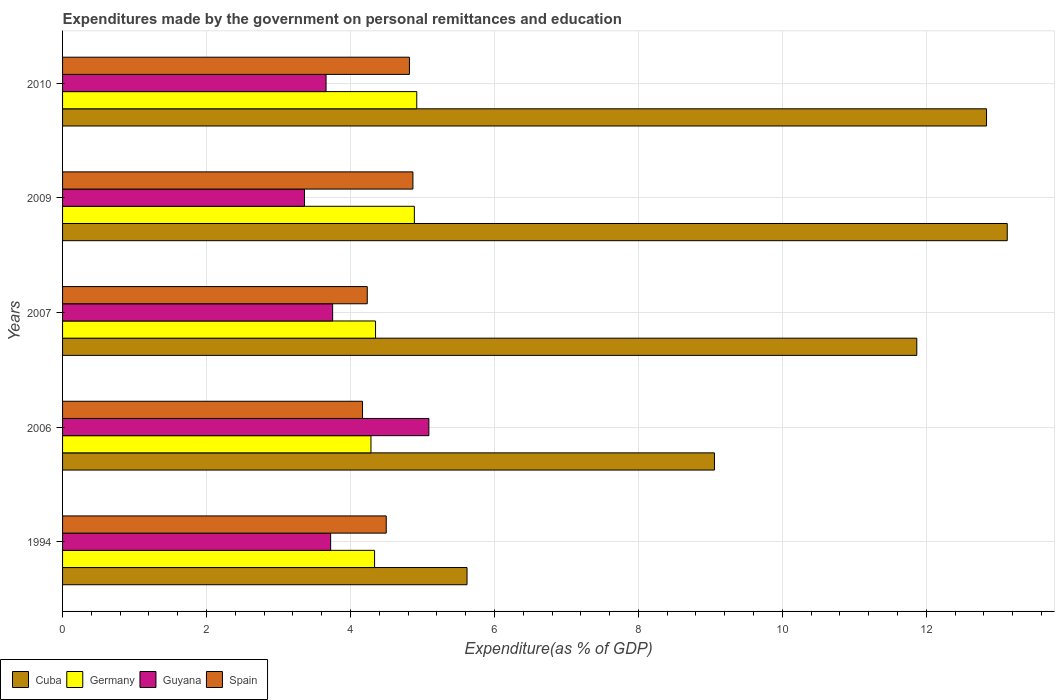Are the number of bars on each tick of the Y-axis equal?
Your answer should be very brief. Yes. How many bars are there on the 1st tick from the top?
Your answer should be compact. 4. How many bars are there on the 5th tick from the bottom?
Your response must be concise. 4. What is the expenditures made by the government on personal remittances and education in Cuba in 2007?
Your answer should be compact. 11.87. Across all years, what is the maximum expenditures made by the government on personal remittances and education in Spain?
Offer a very short reply. 4.87. Across all years, what is the minimum expenditures made by the government on personal remittances and education in Cuba?
Make the answer very short. 5.62. In which year was the expenditures made by the government on personal remittances and education in Cuba maximum?
Your answer should be compact. 2009. In which year was the expenditures made by the government on personal remittances and education in Germany minimum?
Ensure brevity in your answer.  2006. What is the total expenditures made by the government on personal remittances and education in Spain in the graph?
Provide a short and direct response. 22.58. What is the difference between the expenditures made by the government on personal remittances and education in Spain in 2007 and that in 2009?
Offer a very short reply. -0.63. What is the difference between the expenditures made by the government on personal remittances and education in Germany in 2010 and the expenditures made by the government on personal remittances and education in Cuba in 2006?
Offer a very short reply. -4.14. What is the average expenditures made by the government on personal remittances and education in Spain per year?
Provide a short and direct response. 4.52. In the year 2007, what is the difference between the expenditures made by the government on personal remittances and education in Germany and expenditures made by the government on personal remittances and education in Guyana?
Offer a very short reply. 0.6. What is the ratio of the expenditures made by the government on personal remittances and education in Cuba in 2006 to that in 2009?
Your answer should be compact. 0.69. Is the expenditures made by the government on personal remittances and education in Guyana in 1994 less than that in 2009?
Your answer should be compact. No. Is the difference between the expenditures made by the government on personal remittances and education in Germany in 1994 and 2006 greater than the difference between the expenditures made by the government on personal remittances and education in Guyana in 1994 and 2006?
Offer a terse response. Yes. What is the difference between the highest and the second highest expenditures made by the government on personal remittances and education in Spain?
Provide a short and direct response. 0.05. What is the difference between the highest and the lowest expenditures made by the government on personal remittances and education in Germany?
Your response must be concise. 0.64. In how many years, is the expenditures made by the government on personal remittances and education in Germany greater than the average expenditures made by the government on personal remittances and education in Germany taken over all years?
Your response must be concise. 2. Is the sum of the expenditures made by the government on personal remittances and education in Guyana in 2006 and 2007 greater than the maximum expenditures made by the government on personal remittances and education in Spain across all years?
Your response must be concise. Yes. Is it the case that in every year, the sum of the expenditures made by the government on personal remittances and education in Cuba and expenditures made by the government on personal remittances and education in Guyana is greater than the sum of expenditures made by the government on personal remittances and education in Spain and expenditures made by the government on personal remittances and education in Germany?
Provide a succinct answer. Yes. What does the 3rd bar from the top in 2010 represents?
Provide a short and direct response. Germany. How many years are there in the graph?
Make the answer very short. 5. How are the legend labels stacked?
Your response must be concise. Horizontal. What is the title of the graph?
Provide a succinct answer. Expenditures made by the government on personal remittances and education. What is the label or title of the X-axis?
Provide a succinct answer. Expenditure(as % of GDP). What is the Expenditure(as % of GDP) of Cuba in 1994?
Ensure brevity in your answer.  5.62. What is the Expenditure(as % of GDP) of Germany in 1994?
Provide a succinct answer. 4.33. What is the Expenditure(as % of GDP) of Guyana in 1994?
Keep it short and to the point. 3.72. What is the Expenditure(as % of GDP) in Spain in 1994?
Your answer should be compact. 4.5. What is the Expenditure(as % of GDP) in Cuba in 2006?
Ensure brevity in your answer.  9.06. What is the Expenditure(as % of GDP) in Germany in 2006?
Make the answer very short. 4.28. What is the Expenditure(as % of GDP) of Guyana in 2006?
Your answer should be compact. 5.09. What is the Expenditure(as % of GDP) in Spain in 2006?
Your answer should be very brief. 4.17. What is the Expenditure(as % of GDP) in Cuba in 2007?
Ensure brevity in your answer.  11.87. What is the Expenditure(as % of GDP) of Germany in 2007?
Your answer should be compact. 4.35. What is the Expenditure(as % of GDP) in Guyana in 2007?
Make the answer very short. 3.75. What is the Expenditure(as % of GDP) in Spain in 2007?
Offer a terse response. 4.23. What is the Expenditure(as % of GDP) of Cuba in 2009?
Give a very brief answer. 13.13. What is the Expenditure(as % of GDP) in Germany in 2009?
Give a very brief answer. 4.89. What is the Expenditure(as % of GDP) of Guyana in 2009?
Offer a very short reply. 3.36. What is the Expenditure(as % of GDP) of Spain in 2009?
Offer a very short reply. 4.87. What is the Expenditure(as % of GDP) of Cuba in 2010?
Your response must be concise. 12.84. What is the Expenditure(as % of GDP) of Germany in 2010?
Ensure brevity in your answer.  4.92. What is the Expenditure(as % of GDP) in Guyana in 2010?
Your answer should be compact. 3.66. What is the Expenditure(as % of GDP) in Spain in 2010?
Your response must be concise. 4.82. Across all years, what is the maximum Expenditure(as % of GDP) in Cuba?
Your answer should be very brief. 13.13. Across all years, what is the maximum Expenditure(as % of GDP) in Germany?
Your answer should be compact. 4.92. Across all years, what is the maximum Expenditure(as % of GDP) of Guyana?
Your answer should be very brief. 5.09. Across all years, what is the maximum Expenditure(as % of GDP) in Spain?
Offer a very short reply. 4.87. Across all years, what is the minimum Expenditure(as % of GDP) of Cuba?
Offer a very short reply. 5.62. Across all years, what is the minimum Expenditure(as % of GDP) in Germany?
Give a very brief answer. 4.28. Across all years, what is the minimum Expenditure(as % of GDP) of Guyana?
Offer a terse response. 3.36. Across all years, what is the minimum Expenditure(as % of GDP) of Spain?
Give a very brief answer. 4.17. What is the total Expenditure(as % of GDP) of Cuba in the graph?
Give a very brief answer. 52.51. What is the total Expenditure(as % of GDP) in Germany in the graph?
Offer a terse response. 22.78. What is the total Expenditure(as % of GDP) of Guyana in the graph?
Your response must be concise. 19.59. What is the total Expenditure(as % of GDP) of Spain in the graph?
Your answer should be very brief. 22.58. What is the difference between the Expenditure(as % of GDP) of Cuba in 1994 and that in 2006?
Give a very brief answer. -3.44. What is the difference between the Expenditure(as % of GDP) of Germany in 1994 and that in 2006?
Your answer should be very brief. 0.05. What is the difference between the Expenditure(as % of GDP) of Guyana in 1994 and that in 2006?
Offer a terse response. -1.36. What is the difference between the Expenditure(as % of GDP) of Spain in 1994 and that in 2006?
Keep it short and to the point. 0.33. What is the difference between the Expenditure(as % of GDP) of Cuba in 1994 and that in 2007?
Ensure brevity in your answer.  -6.25. What is the difference between the Expenditure(as % of GDP) of Germany in 1994 and that in 2007?
Your answer should be compact. -0.01. What is the difference between the Expenditure(as % of GDP) of Guyana in 1994 and that in 2007?
Provide a succinct answer. -0.03. What is the difference between the Expenditure(as % of GDP) in Spain in 1994 and that in 2007?
Offer a terse response. 0.26. What is the difference between the Expenditure(as % of GDP) of Cuba in 1994 and that in 2009?
Your response must be concise. -7.51. What is the difference between the Expenditure(as % of GDP) in Germany in 1994 and that in 2009?
Your response must be concise. -0.55. What is the difference between the Expenditure(as % of GDP) of Guyana in 1994 and that in 2009?
Make the answer very short. 0.36. What is the difference between the Expenditure(as % of GDP) of Spain in 1994 and that in 2009?
Provide a succinct answer. -0.37. What is the difference between the Expenditure(as % of GDP) of Cuba in 1994 and that in 2010?
Make the answer very short. -7.22. What is the difference between the Expenditure(as % of GDP) of Germany in 1994 and that in 2010?
Provide a short and direct response. -0.59. What is the difference between the Expenditure(as % of GDP) in Guyana in 1994 and that in 2010?
Your response must be concise. 0.06. What is the difference between the Expenditure(as % of GDP) in Spain in 1994 and that in 2010?
Provide a short and direct response. -0.32. What is the difference between the Expenditure(as % of GDP) in Cuba in 2006 and that in 2007?
Make the answer very short. -2.81. What is the difference between the Expenditure(as % of GDP) of Germany in 2006 and that in 2007?
Provide a succinct answer. -0.06. What is the difference between the Expenditure(as % of GDP) in Guyana in 2006 and that in 2007?
Provide a succinct answer. 1.34. What is the difference between the Expenditure(as % of GDP) in Spain in 2006 and that in 2007?
Provide a succinct answer. -0.07. What is the difference between the Expenditure(as % of GDP) of Cuba in 2006 and that in 2009?
Provide a succinct answer. -4.07. What is the difference between the Expenditure(as % of GDP) of Germany in 2006 and that in 2009?
Offer a terse response. -0.6. What is the difference between the Expenditure(as % of GDP) in Guyana in 2006 and that in 2009?
Make the answer very short. 1.73. What is the difference between the Expenditure(as % of GDP) in Spain in 2006 and that in 2009?
Offer a very short reply. -0.7. What is the difference between the Expenditure(as % of GDP) of Cuba in 2006 and that in 2010?
Provide a short and direct response. -3.78. What is the difference between the Expenditure(as % of GDP) in Germany in 2006 and that in 2010?
Make the answer very short. -0.64. What is the difference between the Expenditure(as % of GDP) in Guyana in 2006 and that in 2010?
Make the answer very short. 1.43. What is the difference between the Expenditure(as % of GDP) in Spain in 2006 and that in 2010?
Your answer should be compact. -0.65. What is the difference between the Expenditure(as % of GDP) in Cuba in 2007 and that in 2009?
Provide a succinct answer. -1.26. What is the difference between the Expenditure(as % of GDP) of Germany in 2007 and that in 2009?
Keep it short and to the point. -0.54. What is the difference between the Expenditure(as % of GDP) in Guyana in 2007 and that in 2009?
Ensure brevity in your answer.  0.39. What is the difference between the Expenditure(as % of GDP) in Spain in 2007 and that in 2009?
Your response must be concise. -0.63. What is the difference between the Expenditure(as % of GDP) in Cuba in 2007 and that in 2010?
Make the answer very short. -0.97. What is the difference between the Expenditure(as % of GDP) in Germany in 2007 and that in 2010?
Provide a succinct answer. -0.57. What is the difference between the Expenditure(as % of GDP) of Guyana in 2007 and that in 2010?
Your answer should be very brief. 0.09. What is the difference between the Expenditure(as % of GDP) of Spain in 2007 and that in 2010?
Ensure brevity in your answer.  -0.59. What is the difference between the Expenditure(as % of GDP) of Cuba in 2009 and that in 2010?
Your answer should be very brief. 0.29. What is the difference between the Expenditure(as % of GDP) of Germany in 2009 and that in 2010?
Keep it short and to the point. -0.03. What is the difference between the Expenditure(as % of GDP) of Guyana in 2009 and that in 2010?
Keep it short and to the point. -0.3. What is the difference between the Expenditure(as % of GDP) of Spain in 2009 and that in 2010?
Provide a short and direct response. 0.05. What is the difference between the Expenditure(as % of GDP) of Cuba in 1994 and the Expenditure(as % of GDP) of Germany in 2006?
Make the answer very short. 1.33. What is the difference between the Expenditure(as % of GDP) of Cuba in 1994 and the Expenditure(as % of GDP) of Guyana in 2006?
Your response must be concise. 0.53. What is the difference between the Expenditure(as % of GDP) in Cuba in 1994 and the Expenditure(as % of GDP) in Spain in 2006?
Your response must be concise. 1.45. What is the difference between the Expenditure(as % of GDP) of Germany in 1994 and the Expenditure(as % of GDP) of Guyana in 2006?
Make the answer very short. -0.75. What is the difference between the Expenditure(as % of GDP) of Germany in 1994 and the Expenditure(as % of GDP) of Spain in 2006?
Provide a short and direct response. 0.17. What is the difference between the Expenditure(as % of GDP) in Guyana in 1994 and the Expenditure(as % of GDP) in Spain in 2006?
Provide a short and direct response. -0.44. What is the difference between the Expenditure(as % of GDP) of Cuba in 1994 and the Expenditure(as % of GDP) of Germany in 2007?
Offer a terse response. 1.27. What is the difference between the Expenditure(as % of GDP) of Cuba in 1994 and the Expenditure(as % of GDP) of Guyana in 2007?
Keep it short and to the point. 1.87. What is the difference between the Expenditure(as % of GDP) of Cuba in 1994 and the Expenditure(as % of GDP) of Spain in 2007?
Provide a succinct answer. 1.39. What is the difference between the Expenditure(as % of GDP) of Germany in 1994 and the Expenditure(as % of GDP) of Guyana in 2007?
Make the answer very short. 0.58. What is the difference between the Expenditure(as % of GDP) in Germany in 1994 and the Expenditure(as % of GDP) in Spain in 2007?
Your answer should be very brief. 0.1. What is the difference between the Expenditure(as % of GDP) in Guyana in 1994 and the Expenditure(as % of GDP) in Spain in 2007?
Give a very brief answer. -0.51. What is the difference between the Expenditure(as % of GDP) in Cuba in 1994 and the Expenditure(as % of GDP) in Germany in 2009?
Provide a short and direct response. 0.73. What is the difference between the Expenditure(as % of GDP) in Cuba in 1994 and the Expenditure(as % of GDP) in Guyana in 2009?
Your response must be concise. 2.26. What is the difference between the Expenditure(as % of GDP) of Cuba in 1994 and the Expenditure(as % of GDP) of Spain in 2009?
Keep it short and to the point. 0.75. What is the difference between the Expenditure(as % of GDP) of Germany in 1994 and the Expenditure(as % of GDP) of Guyana in 2009?
Ensure brevity in your answer.  0.97. What is the difference between the Expenditure(as % of GDP) in Germany in 1994 and the Expenditure(as % of GDP) in Spain in 2009?
Make the answer very short. -0.53. What is the difference between the Expenditure(as % of GDP) in Guyana in 1994 and the Expenditure(as % of GDP) in Spain in 2009?
Give a very brief answer. -1.14. What is the difference between the Expenditure(as % of GDP) in Cuba in 1994 and the Expenditure(as % of GDP) in Germany in 2010?
Ensure brevity in your answer.  0.7. What is the difference between the Expenditure(as % of GDP) in Cuba in 1994 and the Expenditure(as % of GDP) in Guyana in 2010?
Your answer should be compact. 1.96. What is the difference between the Expenditure(as % of GDP) in Cuba in 1994 and the Expenditure(as % of GDP) in Spain in 2010?
Offer a terse response. 0.8. What is the difference between the Expenditure(as % of GDP) in Germany in 1994 and the Expenditure(as % of GDP) in Guyana in 2010?
Your answer should be very brief. 0.67. What is the difference between the Expenditure(as % of GDP) in Germany in 1994 and the Expenditure(as % of GDP) in Spain in 2010?
Offer a terse response. -0.48. What is the difference between the Expenditure(as % of GDP) of Guyana in 1994 and the Expenditure(as % of GDP) of Spain in 2010?
Provide a succinct answer. -1.09. What is the difference between the Expenditure(as % of GDP) of Cuba in 2006 and the Expenditure(as % of GDP) of Germany in 2007?
Provide a succinct answer. 4.71. What is the difference between the Expenditure(as % of GDP) of Cuba in 2006 and the Expenditure(as % of GDP) of Guyana in 2007?
Offer a terse response. 5.3. What is the difference between the Expenditure(as % of GDP) of Cuba in 2006 and the Expenditure(as % of GDP) of Spain in 2007?
Give a very brief answer. 4.82. What is the difference between the Expenditure(as % of GDP) in Germany in 2006 and the Expenditure(as % of GDP) in Guyana in 2007?
Your answer should be compact. 0.53. What is the difference between the Expenditure(as % of GDP) in Germany in 2006 and the Expenditure(as % of GDP) in Spain in 2007?
Make the answer very short. 0.05. What is the difference between the Expenditure(as % of GDP) of Guyana in 2006 and the Expenditure(as % of GDP) of Spain in 2007?
Offer a terse response. 0.86. What is the difference between the Expenditure(as % of GDP) of Cuba in 2006 and the Expenditure(as % of GDP) of Germany in 2009?
Offer a very short reply. 4.17. What is the difference between the Expenditure(as % of GDP) of Cuba in 2006 and the Expenditure(as % of GDP) of Guyana in 2009?
Your answer should be very brief. 5.7. What is the difference between the Expenditure(as % of GDP) in Cuba in 2006 and the Expenditure(as % of GDP) in Spain in 2009?
Ensure brevity in your answer.  4.19. What is the difference between the Expenditure(as % of GDP) of Germany in 2006 and the Expenditure(as % of GDP) of Guyana in 2009?
Provide a succinct answer. 0.92. What is the difference between the Expenditure(as % of GDP) of Germany in 2006 and the Expenditure(as % of GDP) of Spain in 2009?
Offer a terse response. -0.58. What is the difference between the Expenditure(as % of GDP) in Guyana in 2006 and the Expenditure(as % of GDP) in Spain in 2009?
Keep it short and to the point. 0.22. What is the difference between the Expenditure(as % of GDP) in Cuba in 2006 and the Expenditure(as % of GDP) in Germany in 2010?
Ensure brevity in your answer.  4.14. What is the difference between the Expenditure(as % of GDP) in Cuba in 2006 and the Expenditure(as % of GDP) in Guyana in 2010?
Your answer should be compact. 5.4. What is the difference between the Expenditure(as % of GDP) in Cuba in 2006 and the Expenditure(as % of GDP) in Spain in 2010?
Provide a short and direct response. 4.24. What is the difference between the Expenditure(as % of GDP) in Germany in 2006 and the Expenditure(as % of GDP) in Guyana in 2010?
Your response must be concise. 0.62. What is the difference between the Expenditure(as % of GDP) of Germany in 2006 and the Expenditure(as % of GDP) of Spain in 2010?
Offer a terse response. -0.53. What is the difference between the Expenditure(as % of GDP) of Guyana in 2006 and the Expenditure(as % of GDP) of Spain in 2010?
Offer a very short reply. 0.27. What is the difference between the Expenditure(as % of GDP) in Cuba in 2007 and the Expenditure(as % of GDP) in Germany in 2009?
Your response must be concise. 6.98. What is the difference between the Expenditure(as % of GDP) of Cuba in 2007 and the Expenditure(as % of GDP) of Guyana in 2009?
Offer a very short reply. 8.51. What is the difference between the Expenditure(as % of GDP) of Cuba in 2007 and the Expenditure(as % of GDP) of Spain in 2009?
Give a very brief answer. 7. What is the difference between the Expenditure(as % of GDP) in Germany in 2007 and the Expenditure(as % of GDP) in Guyana in 2009?
Your answer should be compact. 0.99. What is the difference between the Expenditure(as % of GDP) of Germany in 2007 and the Expenditure(as % of GDP) of Spain in 2009?
Keep it short and to the point. -0.52. What is the difference between the Expenditure(as % of GDP) of Guyana in 2007 and the Expenditure(as % of GDP) of Spain in 2009?
Provide a short and direct response. -1.12. What is the difference between the Expenditure(as % of GDP) of Cuba in 2007 and the Expenditure(as % of GDP) of Germany in 2010?
Offer a very short reply. 6.95. What is the difference between the Expenditure(as % of GDP) of Cuba in 2007 and the Expenditure(as % of GDP) of Guyana in 2010?
Offer a terse response. 8.21. What is the difference between the Expenditure(as % of GDP) of Cuba in 2007 and the Expenditure(as % of GDP) of Spain in 2010?
Offer a very short reply. 7.05. What is the difference between the Expenditure(as % of GDP) of Germany in 2007 and the Expenditure(as % of GDP) of Guyana in 2010?
Give a very brief answer. 0.69. What is the difference between the Expenditure(as % of GDP) in Germany in 2007 and the Expenditure(as % of GDP) in Spain in 2010?
Your answer should be compact. -0.47. What is the difference between the Expenditure(as % of GDP) in Guyana in 2007 and the Expenditure(as % of GDP) in Spain in 2010?
Ensure brevity in your answer.  -1.07. What is the difference between the Expenditure(as % of GDP) of Cuba in 2009 and the Expenditure(as % of GDP) of Germany in 2010?
Offer a very short reply. 8.2. What is the difference between the Expenditure(as % of GDP) of Cuba in 2009 and the Expenditure(as % of GDP) of Guyana in 2010?
Your answer should be compact. 9.46. What is the difference between the Expenditure(as % of GDP) in Cuba in 2009 and the Expenditure(as % of GDP) in Spain in 2010?
Give a very brief answer. 8.31. What is the difference between the Expenditure(as % of GDP) in Germany in 2009 and the Expenditure(as % of GDP) in Guyana in 2010?
Provide a short and direct response. 1.23. What is the difference between the Expenditure(as % of GDP) in Germany in 2009 and the Expenditure(as % of GDP) in Spain in 2010?
Offer a terse response. 0.07. What is the difference between the Expenditure(as % of GDP) in Guyana in 2009 and the Expenditure(as % of GDP) in Spain in 2010?
Keep it short and to the point. -1.46. What is the average Expenditure(as % of GDP) of Cuba per year?
Your answer should be compact. 10.5. What is the average Expenditure(as % of GDP) in Germany per year?
Provide a short and direct response. 4.56. What is the average Expenditure(as % of GDP) in Guyana per year?
Offer a very short reply. 3.92. What is the average Expenditure(as % of GDP) in Spain per year?
Keep it short and to the point. 4.52. In the year 1994, what is the difference between the Expenditure(as % of GDP) in Cuba and Expenditure(as % of GDP) in Germany?
Ensure brevity in your answer.  1.28. In the year 1994, what is the difference between the Expenditure(as % of GDP) of Cuba and Expenditure(as % of GDP) of Guyana?
Give a very brief answer. 1.9. In the year 1994, what is the difference between the Expenditure(as % of GDP) in Cuba and Expenditure(as % of GDP) in Spain?
Offer a terse response. 1.12. In the year 1994, what is the difference between the Expenditure(as % of GDP) in Germany and Expenditure(as % of GDP) in Guyana?
Offer a terse response. 0.61. In the year 1994, what is the difference between the Expenditure(as % of GDP) of Germany and Expenditure(as % of GDP) of Spain?
Your response must be concise. -0.16. In the year 1994, what is the difference between the Expenditure(as % of GDP) in Guyana and Expenditure(as % of GDP) in Spain?
Your answer should be compact. -0.77. In the year 2006, what is the difference between the Expenditure(as % of GDP) in Cuba and Expenditure(as % of GDP) in Germany?
Provide a succinct answer. 4.77. In the year 2006, what is the difference between the Expenditure(as % of GDP) of Cuba and Expenditure(as % of GDP) of Guyana?
Offer a terse response. 3.97. In the year 2006, what is the difference between the Expenditure(as % of GDP) of Cuba and Expenditure(as % of GDP) of Spain?
Make the answer very short. 4.89. In the year 2006, what is the difference between the Expenditure(as % of GDP) of Germany and Expenditure(as % of GDP) of Guyana?
Provide a short and direct response. -0.8. In the year 2006, what is the difference between the Expenditure(as % of GDP) in Germany and Expenditure(as % of GDP) in Spain?
Your answer should be very brief. 0.12. In the year 2006, what is the difference between the Expenditure(as % of GDP) in Guyana and Expenditure(as % of GDP) in Spain?
Your answer should be very brief. 0.92. In the year 2007, what is the difference between the Expenditure(as % of GDP) in Cuba and Expenditure(as % of GDP) in Germany?
Keep it short and to the point. 7.52. In the year 2007, what is the difference between the Expenditure(as % of GDP) in Cuba and Expenditure(as % of GDP) in Guyana?
Your answer should be very brief. 8.12. In the year 2007, what is the difference between the Expenditure(as % of GDP) in Cuba and Expenditure(as % of GDP) in Spain?
Offer a very short reply. 7.63. In the year 2007, what is the difference between the Expenditure(as % of GDP) in Germany and Expenditure(as % of GDP) in Guyana?
Your answer should be very brief. 0.6. In the year 2007, what is the difference between the Expenditure(as % of GDP) in Germany and Expenditure(as % of GDP) in Spain?
Provide a succinct answer. 0.12. In the year 2007, what is the difference between the Expenditure(as % of GDP) of Guyana and Expenditure(as % of GDP) of Spain?
Offer a terse response. -0.48. In the year 2009, what is the difference between the Expenditure(as % of GDP) in Cuba and Expenditure(as % of GDP) in Germany?
Your answer should be very brief. 8.24. In the year 2009, what is the difference between the Expenditure(as % of GDP) in Cuba and Expenditure(as % of GDP) in Guyana?
Offer a very short reply. 9.76. In the year 2009, what is the difference between the Expenditure(as % of GDP) in Cuba and Expenditure(as % of GDP) in Spain?
Your answer should be compact. 8.26. In the year 2009, what is the difference between the Expenditure(as % of GDP) in Germany and Expenditure(as % of GDP) in Guyana?
Offer a terse response. 1.53. In the year 2009, what is the difference between the Expenditure(as % of GDP) in Germany and Expenditure(as % of GDP) in Spain?
Provide a succinct answer. 0.02. In the year 2009, what is the difference between the Expenditure(as % of GDP) in Guyana and Expenditure(as % of GDP) in Spain?
Provide a succinct answer. -1.51. In the year 2010, what is the difference between the Expenditure(as % of GDP) of Cuba and Expenditure(as % of GDP) of Germany?
Offer a very short reply. 7.92. In the year 2010, what is the difference between the Expenditure(as % of GDP) of Cuba and Expenditure(as % of GDP) of Guyana?
Give a very brief answer. 9.18. In the year 2010, what is the difference between the Expenditure(as % of GDP) in Cuba and Expenditure(as % of GDP) in Spain?
Keep it short and to the point. 8.02. In the year 2010, what is the difference between the Expenditure(as % of GDP) of Germany and Expenditure(as % of GDP) of Guyana?
Provide a succinct answer. 1.26. In the year 2010, what is the difference between the Expenditure(as % of GDP) of Germany and Expenditure(as % of GDP) of Spain?
Offer a terse response. 0.1. In the year 2010, what is the difference between the Expenditure(as % of GDP) in Guyana and Expenditure(as % of GDP) in Spain?
Your answer should be very brief. -1.16. What is the ratio of the Expenditure(as % of GDP) of Cuba in 1994 to that in 2006?
Give a very brief answer. 0.62. What is the ratio of the Expenditure(as % of GDP) of Germany in 1994 to that in 2006?
Make the answer very short. 1.01. What is the ratio of the Expenditure(as % of GDP) in Guyana in 1994 to that in 2006?
Make the answer very short. 0.73. What is the ratio of the Expenditure(as % of GDP) of Spain in 1994 to that in 2006?
Your answer should be very brief. 1.08. What is the ratio of the Expenditure(as % of GDP) in Cuba in 1994 to that in 2007?
Make the answer very short. 0.47. What is the ratio of the Expenditure(as % of GDP) in Guyana in 1994 to that in 2007?
Offer a very short reply. 0.99. What is the ratio of the Expenditure(as % of GDP) in Spain in 1994 to that in 2007?
Provide a succinct answer. 1.06. What is the ratio of the Expenditure(as % of GDP) of Cuba in 1994 to that in 2009?
Provide a succinct answer. 0.43. What is the ratio of the Expenditure(as % of GDP) in Germany in 1994 to that in 2009?
Keep it short and to the point. 0.89. What is the ratio of the Expenditure(as % of GDP) in Guyana in 1994 to that in 2009?
Ensure brevity in your answer.  1.11. What is the ratio of the Expenditure(as % of GDP) in Spain in 1994 to that in 2009?
Provide a short and direct response. 0.92. What is the ratio of the Expenditure(as % of GDP) of Cuba in 1994 to that in 2010?
Keep it short and to the point. 0.44. What is the ratio of the Expenditure(as % of GDP) in Germany in 1994 to that in 2010?
Offer a very short reply. 0.88. What is the ratio of the Expenditure(as % of GDP) in Guyana in 1994 to that in 2010?
Make the answer very short. 1.02. What is the ratio of the Expenditure(as % of GDP) of Spain in 1994 to that in 2010?
Your answer should be very brief. 0.93. What is the ratio of the Expenditure(as % of GDP) of Cuba in 2006 to that in 2007?
Keep it short and to the point. 0.76. What is the ratio of the Expenditure(as % of GDP) of Germany in 2006 to that in 2007?
Keep it short and to the point. 0.99. What is the ratio of the Expenditure(as % of GDP) of Guyana in 2006 to that in 2007?
Give a very brief answer. 1.36. What is the ratio of the Expenditure(as % of GDP) of Spain in 2006 to that in 2007?
Ensure brevity in your answer.  0.98. What is the ratio of the Expenditure(as % of GDP) of Cuba in 2006 to that in 2009?
Your answer should be very brief. 0.69. What is the ratio of the Expenditure(as % of GDP) of Germany in 2006 to that in 2009?
Make the answer very short. 0.88. What is the ratio of the Expenditure(as % of GDP) in Guyana in 2006 to that in 2009?
Give a very brief answer. 1.51. What is the ratio of the Expenditure(as % of GDP) of Spain in 2006 to that in 2009?
Provide a short and direct response. 0.86. What is the ratio of the Expenditure(as % of GDP) of Cuba in 2006 to that in 2010?
Provide a short and direct response. 0.71. What is the ratio of the Expenditure(as % of GDP) of Germany in 2006 to that in 2010?
Provide a succinct answer. 0.87. What is the ratio of the Expenditure(as % of GDP) of Guyana in 2006 to that in 2010?
Ensure brevity in your answer.  1.39. What is the ratio of the Expenditure(as % of GDP) in Spain in 2006 to that in 2010?
Give a very brief answer. 0.86. What is the ratio of the Expenditure(as % of GDP) of Cuba in 2007 to that in 2009?
Make the answer very short. 0.9. What is the ratio of the Expenditure(as % of GDP) in Germany in 2007 to that in 2009?
Offer a very short reply. 0.89. What is the ratio of the Expenditure(as % of GDP) in Guyana in 2007 to that in 2009?
Give a very brief answer. 1.12. What is the ratio of the Expenditure(as % of GDP) of Spain in 2007 to that in 2009?
Provide a short and direct response. 0.87. What is the ratio of the Expenditure(as % of GDP) in Cuba in 2007 to that in 2010?
Provide a succinct answer. 0.92. What is the ratio of the Expenditure(as % of GDP) of Germany in 2007 to that in 2010?
Give a very brief answer. 0.88. What is the ratio of the Expenditure(as % of GDP) in Guyana in 2007 to that in 2010?
Offer a very short reply. 1.02. What is the ratio of the Expenditure(as % of GDP) of Spain in 2007 to that in 2010?
Give a very brief answer. 0.88. What is the ratio of the Expenditure(as % of GDP) of Cuba in 2009 to that in 2010?
Give a very brief answer. 1.02. What is the ratio of the Expenditure(as % of GDP) in Germany in 2009 to that in 2010?
Your answer should be compact. 0.99. What is the ratio of the Expenditure(as % of GDP) of Guyana in 2009 to that in 2010?
Make the answer very short. 0.92. What is the difference between the highest and the second highest Expenditure(as % of GDP) of Cuba?
Provide a short and direct response. 0.29. What is the difference between the highest and the second highest Expenditure(as % of GDP) in Guyana?
Your answer should be very brief. 1.34. What is the difference between the highest and the second highest Expenditure(as % of GDP) in Spain?
Your answer should be very brief. 0.05. What is the difference between the highest and the lowest Expenditure(as % of GDP) in Cuba?
Provide a short and direct response. 7.51. What is the difference between the highest and the lowest Expenditure(as % of GDP) in Germany?
Offer a terse response. 0.64. What is the difference between the highest and the lowest Expenditure(as % of GDP) of Guyana?
Your answer should be compact. 1.73. What is the difference between the highest and the lowest Expenditure(as % of GDP) of Spain?
Offer a terse response. 0.7. 